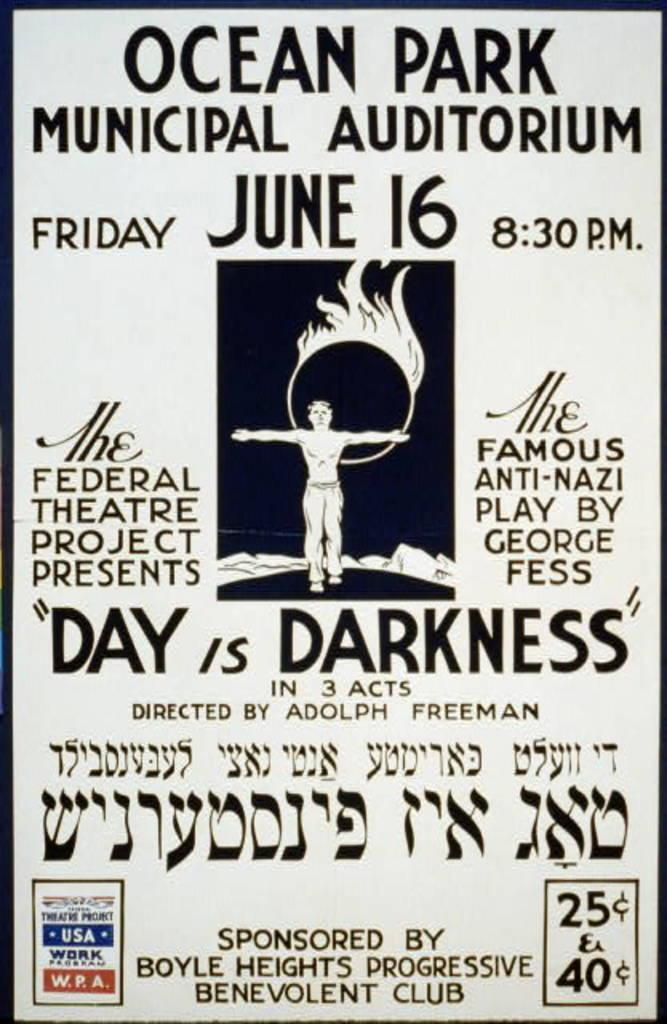<image>
Relay a brief, clear account of the picture shown. A black and white poster advertises the play Day is Darkness on Friday June 16 at 8.30pm 